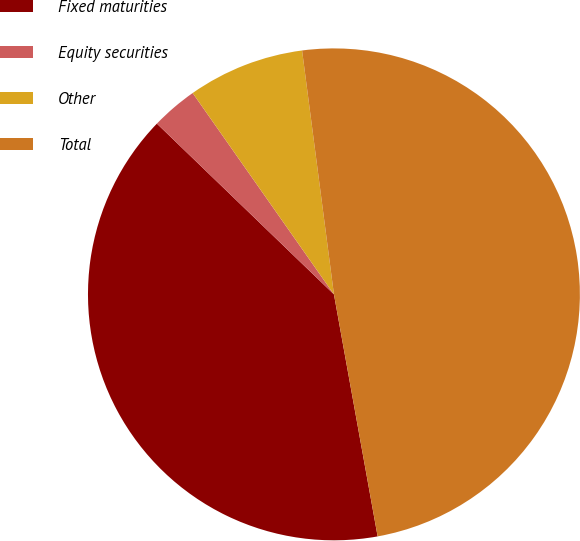Convert chart to OTSL. <chart><loc_0><loc_0><loc_500><loc_500><pie_chart><fcel>Fixed maturities<fcel>Equity securities<fcel>Other<fcel>Total<nl><fcel>40.05%<fcel>3.05%<fcel>7.67%<fcel>49.22%<nl></chart> 